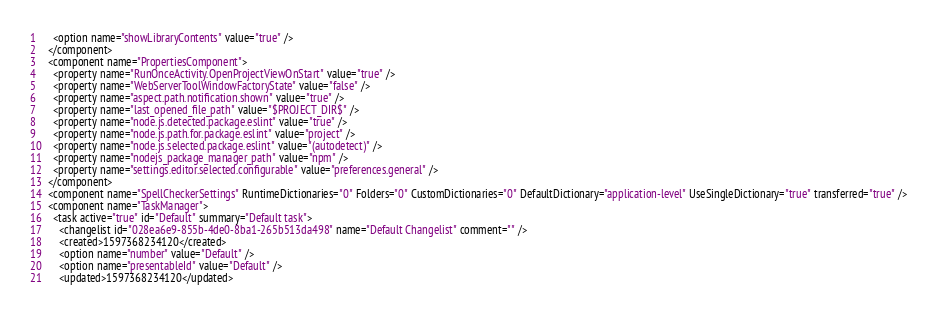<code> <loc_0><loc_0><loc_500><loc_500><_XML_>    <option name="showLibraryContents" value="true" />
  </component>
  <component name="PropertiesComponent">
    <property name="RunOnceActivity.OpenProjectViewOnStart" value="true" />
    <property name="WebServerToolWindowFactoryState" value="false" />
    <property name="aspect.path.notification.shown" value="true" />
    <property name="last_opened_file_path" value="$PROJECT_DIR$" />
    <property name="node.js.detected.package.eslint" value="true" />
    <property name="node.js.path.for.package.eslint" value="project" />
    <property name="node.js.selected.package.eslint" value="(autodetect)" />
    <property name="nodejs_package_manager_path" value="npm" />
    <property name="settings.editor.selected.configurable" value="preferences.general" />
  </component>
  <component name="SpellCheckerSettings" RuntimeDictionaries="0" Folders="0" CustomDictionaries="0" DefaultDictionary="application-level" UseSingleDictionary="true" transferred="true" />
  <component name="TaskManager">
    <task active="true" id="Default" summary="Default task">
      <changelist id="028ea6e9-855b-4de0-8ba1-265b513da498" name="Default Changelist" comment="" />
      <created>1597368234120</created>
      <option name="number" value="Default" />
      <option name="presentableId" value="Default" />
      <updated>1597368234120</updated></code> 